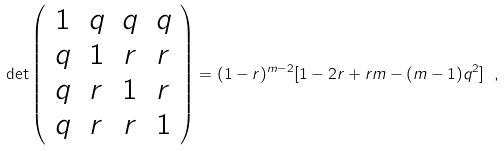<formula> <loc_0><loc_0><loc_500><loc_500>\det \left ( \begin{array} { c c c c } 1 & q & q & q \\ q & 1 & r & r \\ q & r & 1 & r \\ q & r & r & 1 \\ \end{array} \right ) = ( 1 - r ) ^ { m - 2 } [ 1 - 2 r + r m - ( m - 1 ) q ^ { 2 } ] \ ,</formula> 